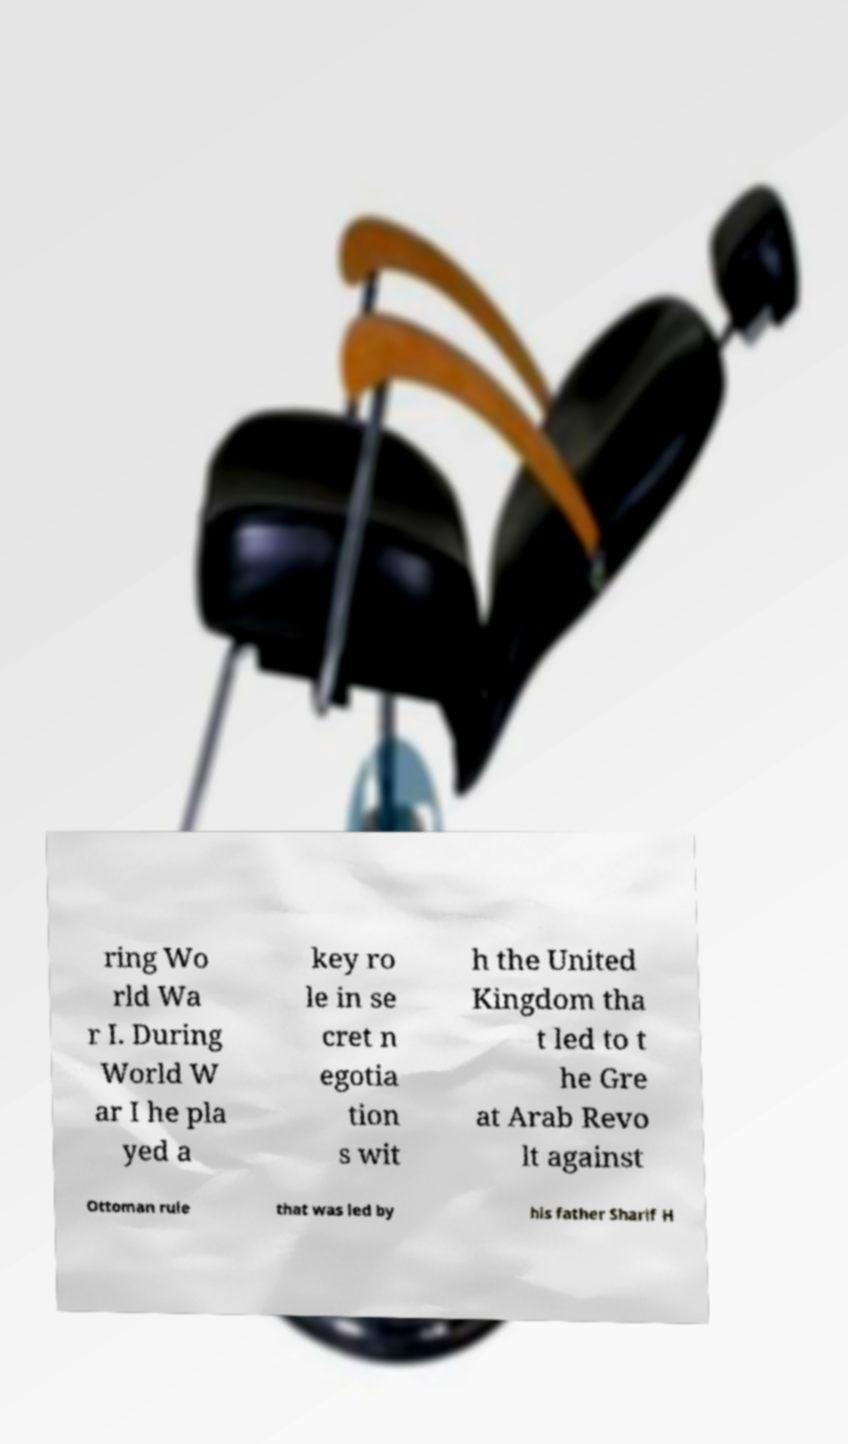Can you accurately transcribe the text from the provided image for me? ring Wo rld Wa r I. During World W ar I he pla yed a key ro le in se cret n egotia tion s wit h the United Kingdom tha t led to t he Gre at Arab Revo lt against Ottoman rule that was led by his father Sharif H 